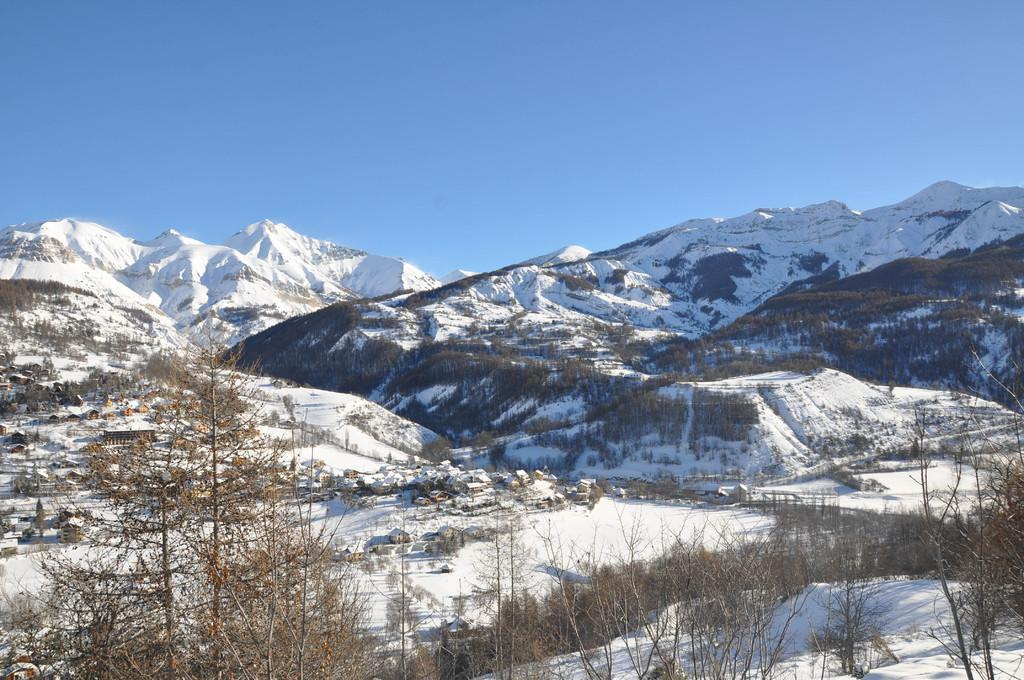What type of vegetation can be seen in the image? There are trees in the image. What is the weather like in the image? There is snow visible in the image, indicating a cold and snowy environment. What can be seen in the background of the image? There are snow mountains and a clear sky in the background of the image. What type of cabbage is growing on the snow mountains in the image? There is no cabbage present in the image, and the snow mountains are not a suitable environment for growing cabbage. 